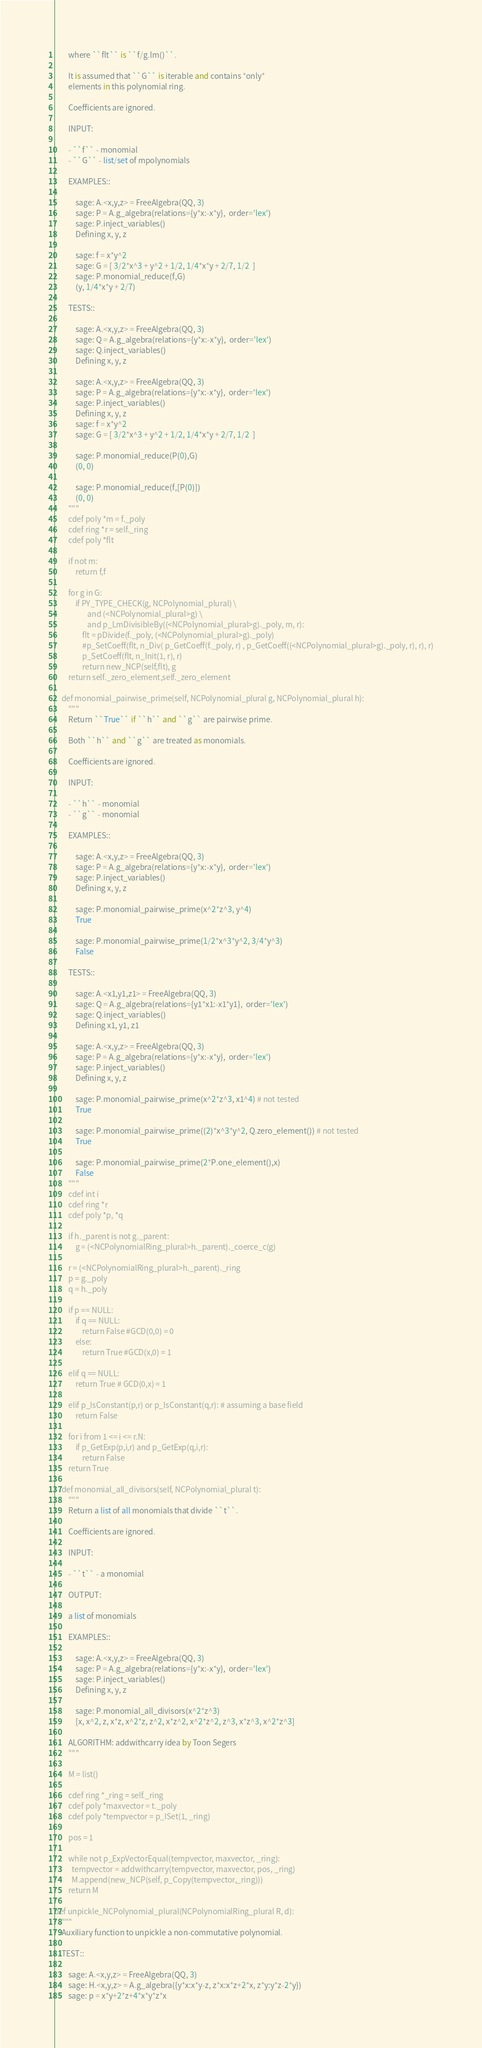<code> <loc_0><loc_0><loc_500><loc_500><_Cython_>        where ``flt`` is ``f/g.lm()``.

        It is assumed that ``G`` is iterable and contains *only*
        elements in this polynomial ring.

        Coefficients are ignored.

        INPUT:

        - ``f`` - monomial
        - ``G`` - list/set of mpolynomials

        EXAMPLES::

            sage: A.<x,y,z> = FreeAlgebra(QQ, 3)
            sage: P = A.g_algebra(relations={y*x:-x*y},  order='lex')
            sage: P.inject_variables()
            Defining x, y, z

            sage: f = x*y^2
            sage: G = [ 3/2*x^3 + y^2 + 1/2, 1/4*x*y + 2/7, 1/2  ]
            sage: P.monomial_reduce(f,G)
            (y, 1/4*x*y + 2/7)

        TESTS::

            sage: A.<x,y,z> = FreeAlgebra(QQ, 3)
            sage: Q = A.g_algebra(relations={y*x:-x*y},  order='lex')
            sage: Q.inject_variables()
            Defining x, y, z

            sage: A.<x,y,z> = FreeAlgebra(QQ, 3)
            sage: P = A.g_algebra(relations={y*x:-x*y},  order='lex')
            sage: P.inject_variables()
            Defining x, y, z
            sage: f = x*y^2
            sage: G = [ 3/2*x^3 + y^2 + 1/2, 1/4*x*y + 2/7, 1/2  ]

            sage: P.monomial_reduce(P(0),G)
            (0, 0)

            sage: P.monomial_reduce(f,[P(0)])
            (0, 0)
        """
        cdef poly *m = f._poly
        cdef ring *r = self._ring
        cdef poly *flt

        if not m:
            return f,f

        for g in G:
            if PY_TYPE_CHECK(g, NCPolynomial_plural) \
                   and (<NCPolynomial_plural>g) \
                   and p_LmDivisibleBy((<NCPolynomial_plural>g)._poly, m, r):
                flt = pDivide(f._poly, (<NCPolynomial_plural>g)._poly)
                #p_SetCoeff(flt, n_Div( p_GetCoeff(f._poly, r) , p_GetCoeff((<NCPolynomial_plural>g)._poly, r), r), r)
                p_SetCoeff(flt, n_Init(1, r), r)
                return new_NCP(self,flt), g
        return self._zero_element,self._zero_element

    def monomial_pairwise_prime(self, NCPolynomial_plural g, NCPolynomial_plural h):
        """
        Return ``True`` if ``h`` and ``g`` are pairwise prime.

        Both ``h`` and ``g`` are treated as monomials.

        Coefficients are ignored.

        INPUT:

        - ``h`` - monomial
        - ``g`` - monomial

        EXAMPLES::

            sage: A.<x,y,z> = FreeAlgebra(QQ, 3)
            sage: P = A.g_algebra(relations={y*x:-x*y},  order='lex')
            sage: P.inject_variables()
            Defining x, y, z

            sage: P.monomial_pairwise_prime(x^2*z^3, y^4)
            True

            sage: P.monomial_pairwise_prime(1/2*x^3*y^2, 3/4*y^3)
            False

        TESTS::

            sage: A.<x1,y1,z1> = FreeAlgebra(QQ, 3)
            sage: Q = A.g_algebra(relations={y1*x1:-x1*y1},  order='lex')
            sage: Q.inject_variables()
            Defining x1, y1, z1

            sage: A.<x,y,z> = FreeAlgebra(QQ, 3)
            sage: P = A.g_algebra(relations={y*x:-x*y},  order='lex')
            sage: P.inject_variables()
            Defining x, y, z

            sage: P.monomial_pairwise_prime(x^2*z^3, x1^4) # not tested
            True

            sage: P.monomial_pairwise_prime((2)*x^3*y^2, Q.zero_element()) # not tested
            True

            sage: P.monomial_pairwise_prime(2*P.one_element(),x)
            False
        """
        cdef int i
        cdef ring *r
        cdef poly *p, *q

        if h._parent is not g._parent:
            g = (<NCPolynomialRing_plural>h._parent)._coerce_c(g)

        r = (<NCPolynomialRing_plural>h._parent)._ring
        p = g._poly
        q = h._poly

        if p == NULL:
            if q == NULL:
                return False #GCD(0,0) = 0
            else:
                return True #GCD(x,0) = 1

        elif q == NULL:
            return True # GCD(0,x) = 1

        elif p_IsConstant(p,r) or p_IsConstant(q,r): # assuming a base field
            return False

        for i from 1 <= i <= r.N:
            if p_GetExp(p,i,r) and p_GetExp(q,i,r):
                return False
        return True

    def monomial_all_divisors(self, NCPolynomial_plural t):
        """
        Return a list of all monomials that divide ``t``.

        Coefficients are ignored.

        INPUT:

        - ``t`` - a monomial

        OUTPUT:

        a list of monomials

        EXAMPLES::

            sage: A.<x,y,z> = FreeAlgebra(QQ, 3)
            sage: P = A.g_algebra(relations={y*x:-x*y},  order='lex')
            sage: P.inject_variables()
            Defining x, y, z

            sage: P.monomial_all_divisors(x^2*z^3)
            [x, x^2, z, x*z, x^2*z, z^2, x*z^2, x^2*z^2, z^3, x*z^3, x^2*z^3]

        ALGORITHM: addwithcarry idea by Toon Segers
        """

        M = list()

        cdef ring *_ring = self._ring
        cdef poly *maxvector = t._poly
        cdef poly *tempvector = p_ISet(1, _ring)

        pos = 1

        while not p_ExpVectorEqual(tempvector, maxvector, _ring):
          tempvector = addwithcarry(tempvector, maxvector, pos, _ring)
          M.append(new_NCP(self, p_Copy(tempvector,_ring)))
        return M

def unpickle_NCPolynomial_plural(NCPolynomialRing_plural R, d):
    """
    Auxiliary function to unpickle a non-commutative polynomial.

    TEST::

        sage: A.<x,y,z> = FreeAlgebra(QQ, 3)
        sage: H.<x,y,z> = A.g_algebra({y*x:x*y-z, z*x:x*z+2*x, z*y:y*z-2*y})
        sage: p = x*y+2*z+4*x*y*z*x</code> 